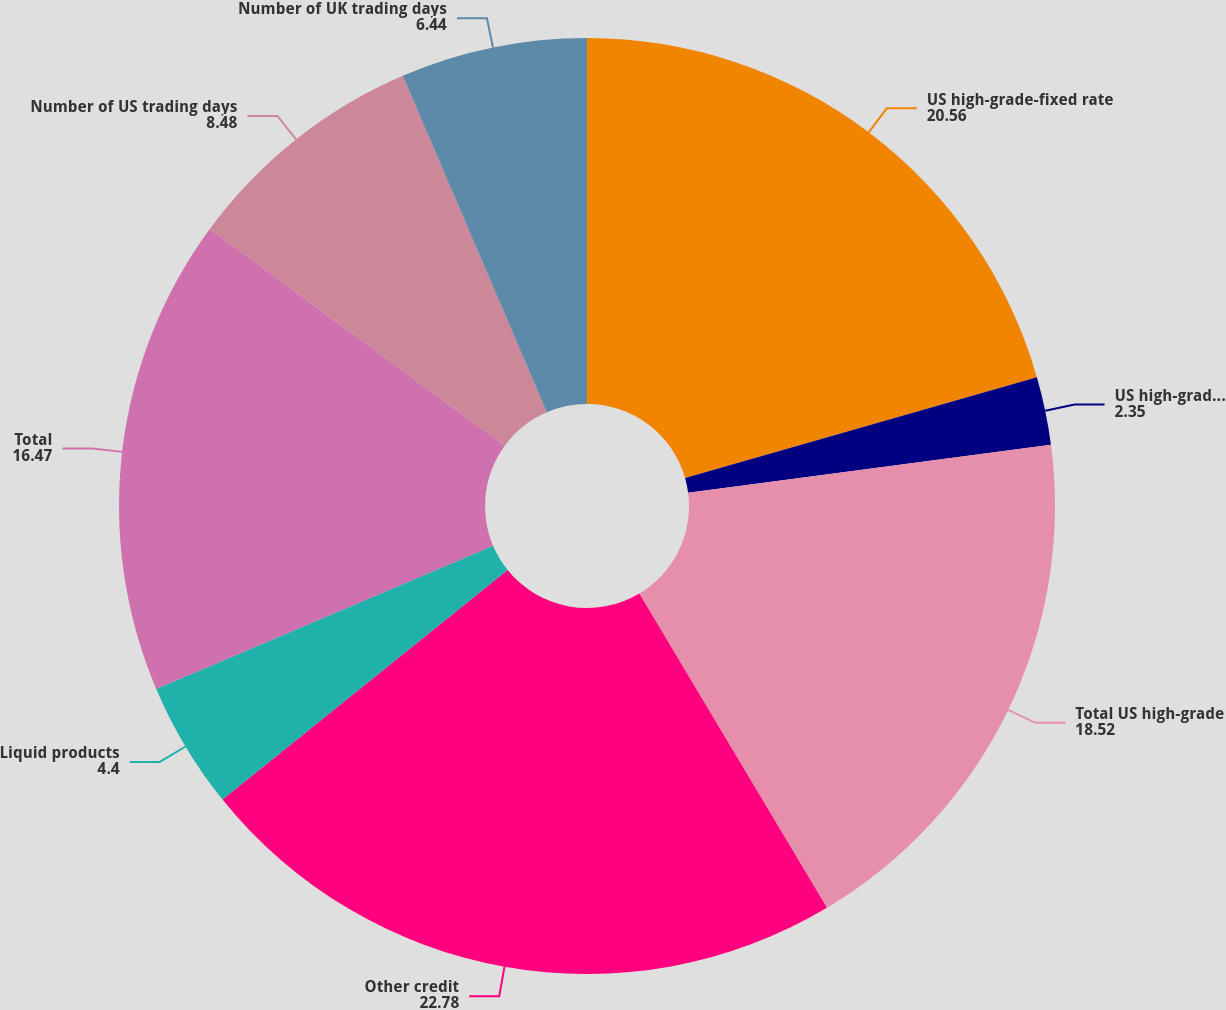Convert chart to OTSL. <chart><loc_0><loc_0><loc_500><loc_500><pie_chart><fcel>US high-grade-fixed rate<fcel>US high-grade-floating rate<fcel>Total US high-grade<fcel>Other credit<fcel>Liquid products<fcel>Total<fcel>Number of US trading days<fcel>Number of UK trading days<nl><fcel>20.56%<fcel>2.35%<fcel>18.52%<fcel>22.78%<fcel>4.4%<fcel>16.47%<fcel>8.48%<fcel>6.44%<nl></chart> 